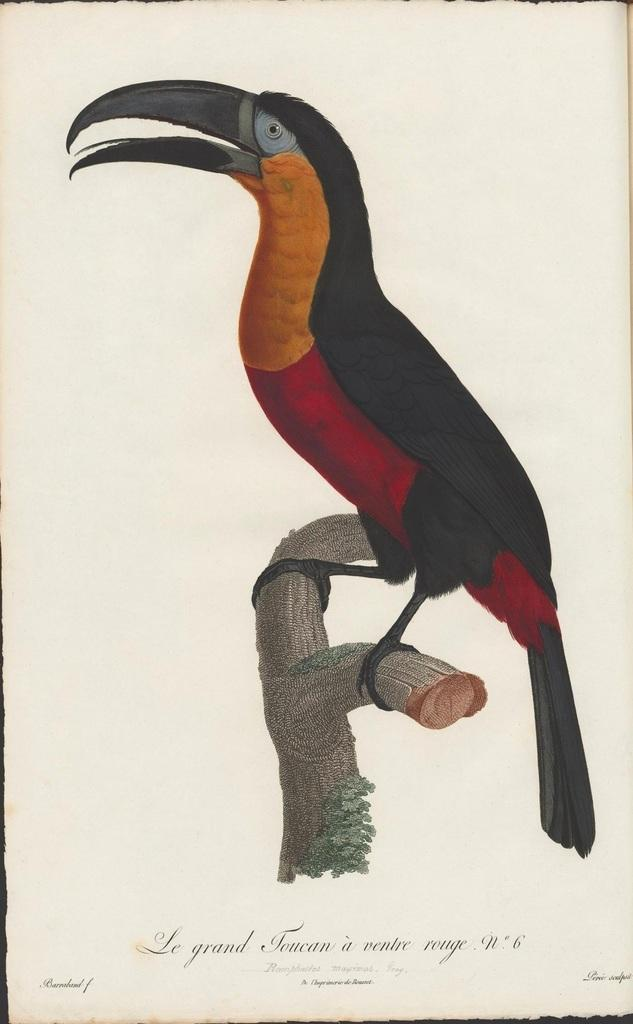What is the main subject of the painting in the image? The painting depicts a bird. Are there any other elements in the painting besides the bird? Yes, the painting also includes a tree stem. What type of cannon is featured in the painting? There is no cannon present in the painting; it features a bird and a tree stem. What hobbies does the bird in the painting enjoy? The painting does not provide information about the bird's hobbies, as it is a static image. 